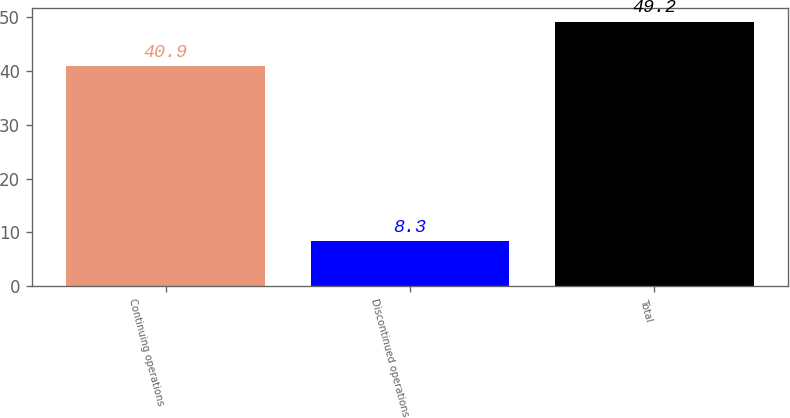Convert chart. <chart><loc_0><loc_0><loc_500><loc_500><bar_chart><fcel>Continuing operations<fcel>Discontinued operations<fcel>Total<nl><fcel>40.9<fcel>8.3<fcel>49.2<nl></chart> 